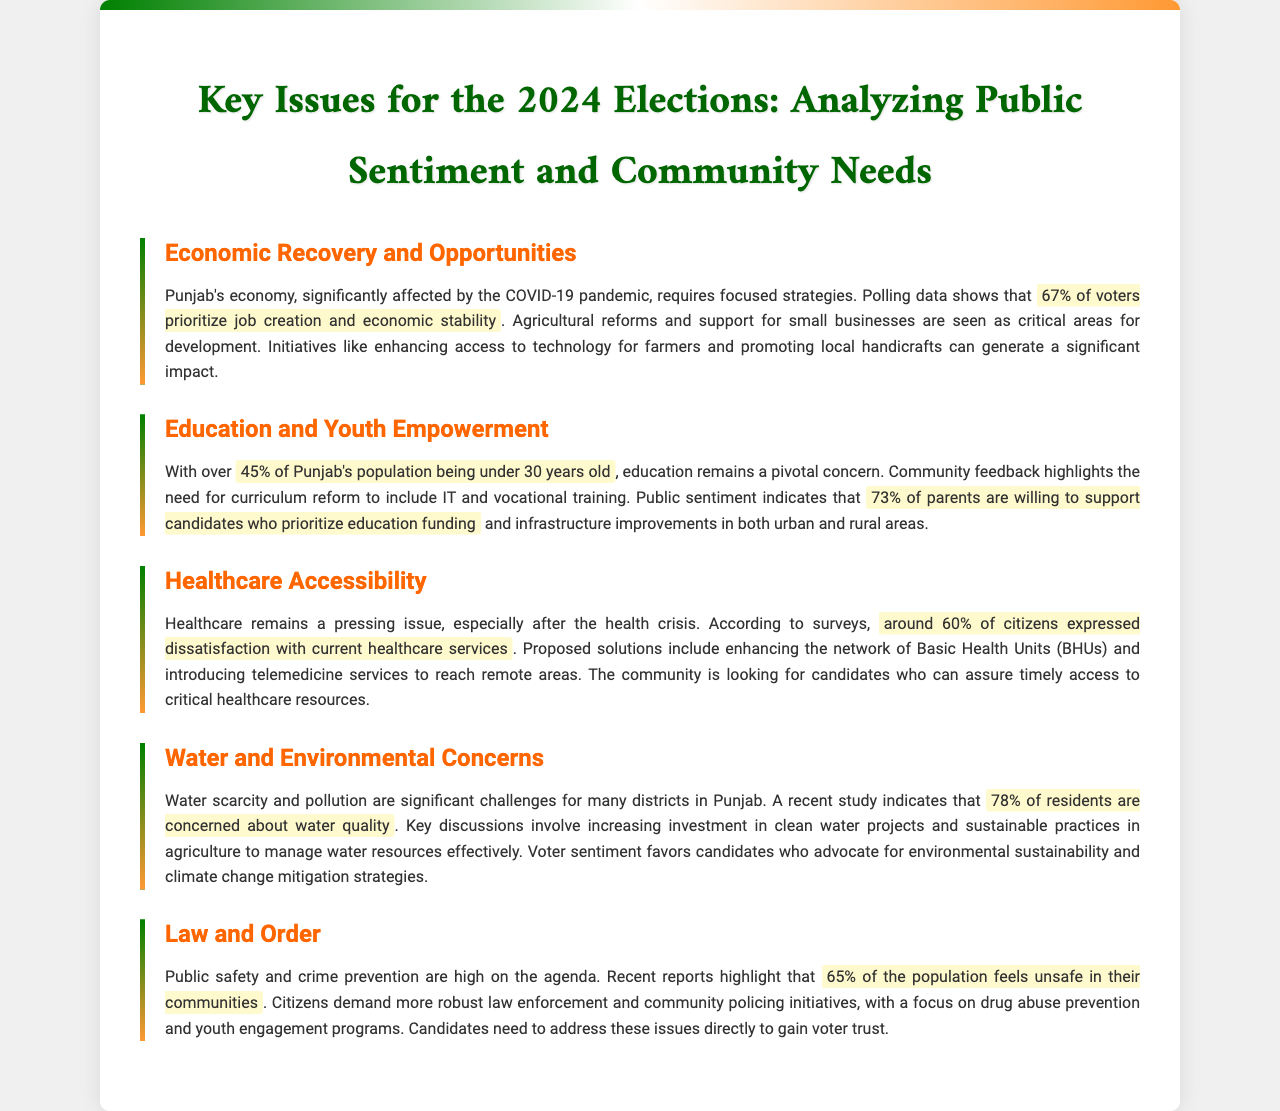What percentage of voters prioritize job creation and economic stability? The document states that 67% of voters prioritize job creation and economic stability as a key issue.
Answer: 67% What is the age group of over 45% of Punjab's population? According to the document, over 45% of Punjab's population is under 30 years old.
Answer: Under 30 years old What percentage of parents support candidates prioritizing education funding? The text indicates that 73% of parents are willing to support candidates who prioritize education funding.
Answer: 73% What percentage of citizens expressed dissatisfaction with current healthcare services? The document mentions that around 60% of citizens expressed dissatisfaction with healthcare services.
Answer: 60% What is the main concern of 78% of residents in Punjab? The document highlights that 78% of residents are concerned about water quality.
Answer: Water quality Which issue is high on the agenda related to public safety? The document points out that law and order, particularly public safety and crime prevention, is high on the agenda.
Answer: Law and order What is a suggested solution for enhancing healthcare accessibility? Proposed solutions include enhancing the network of Basic Health Units (BHUs).
Answer: Basic Health Units (BHUs) What aspect of the economy requires focused strategies according to the document? The document states that Punjab's economy requires focused strategies for recovery and opportunities after COVID-19.
Answer: Economic recovery and opportunities What is the community's stance on environmental sustainability? The document indicates that voter sentiment favors candidates who advocate for environmental sustainability.
Answer: Environmental sustainability 